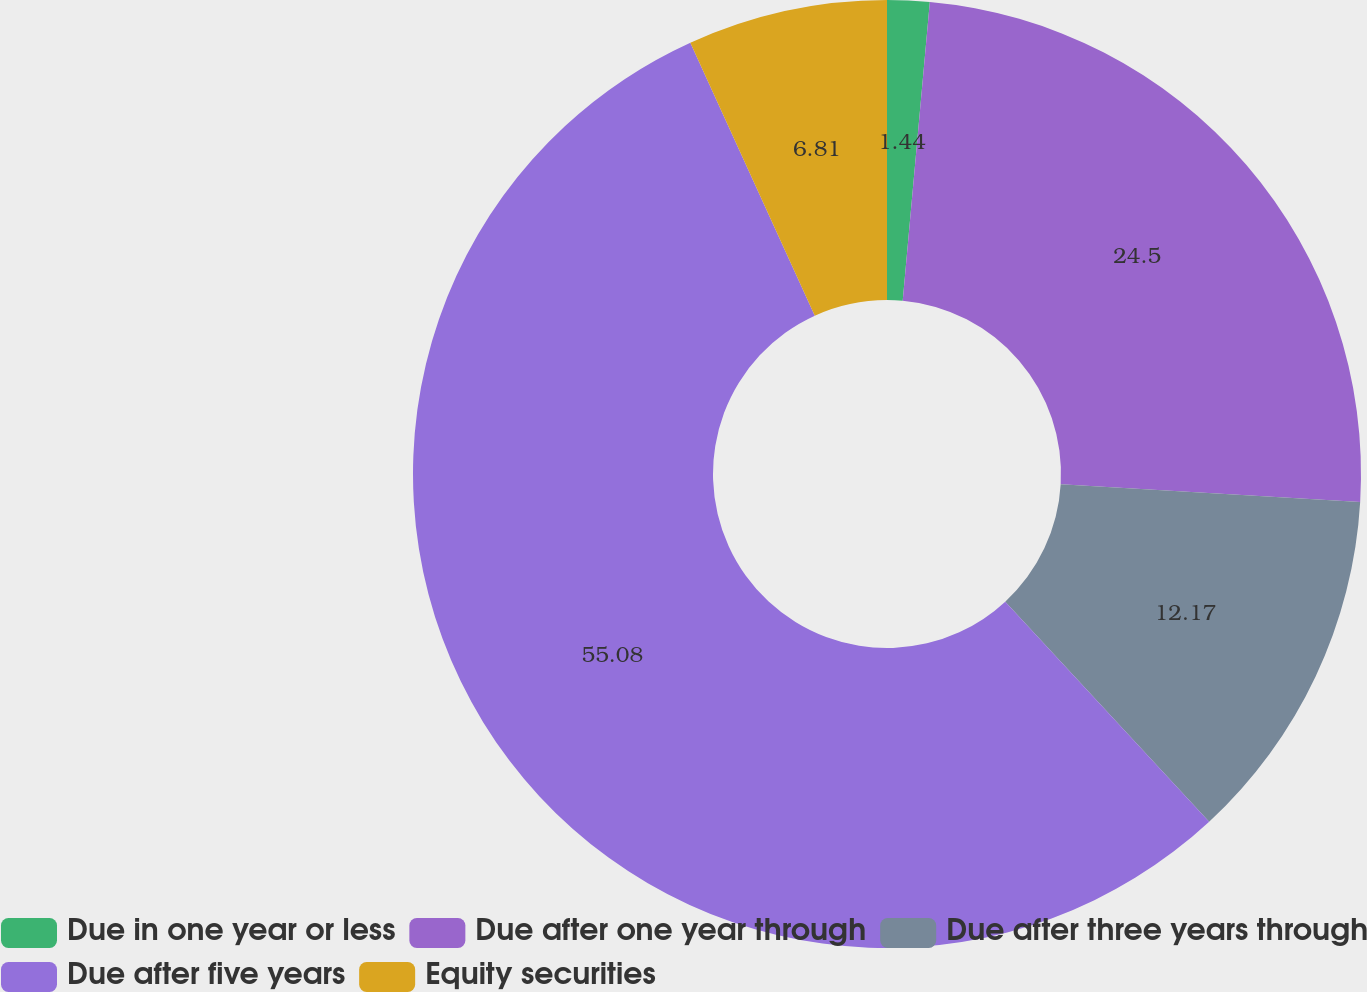Convert chart to OTSL. <chart><loc_0><loc_0><loc_500><loc_500><pie_chart><fcel>Due in one year or less<fcel>Due after one year through<fcel>Due after three years through<fcel>Due after five years<fcel>Equity securities<nl><fcel>1.44%<fcel>24.5%<fcel>12.17%<fcel>55.09%<fcel>6.81%<nl></chart> 